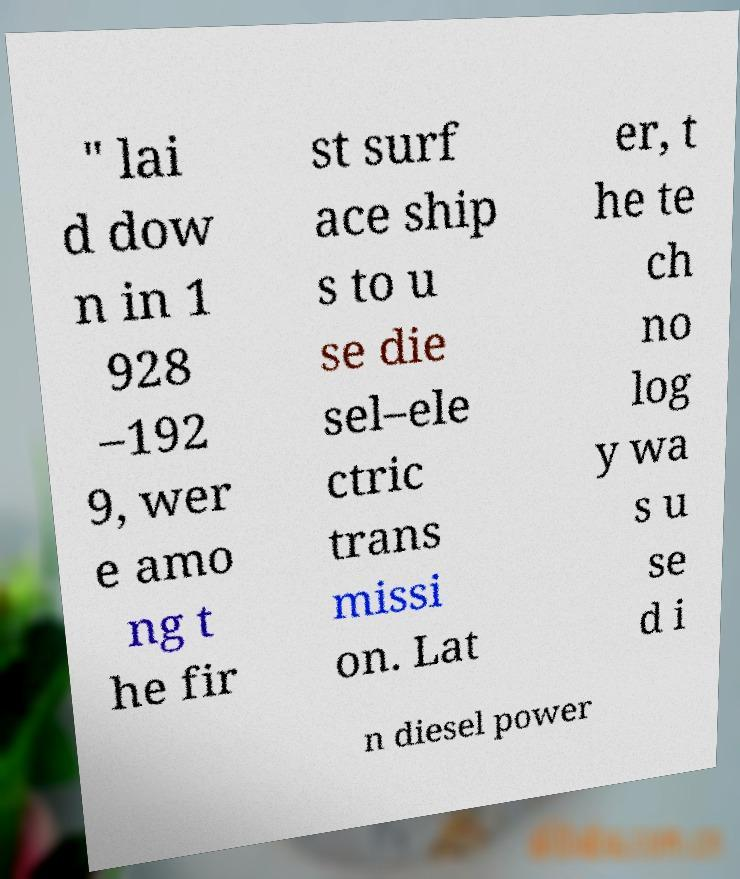Can you read and provide the text displayed in the image?This photo seems to have some interesting text. Can you extract and type it out for me? " lai d dow n in 1 928 –192 9, wer e amo ng t he fir st surf ace ship s to u se die sel–ele ctric trans missi on. Lat er, t he te ch no log y wa s u se d i n diesel power 